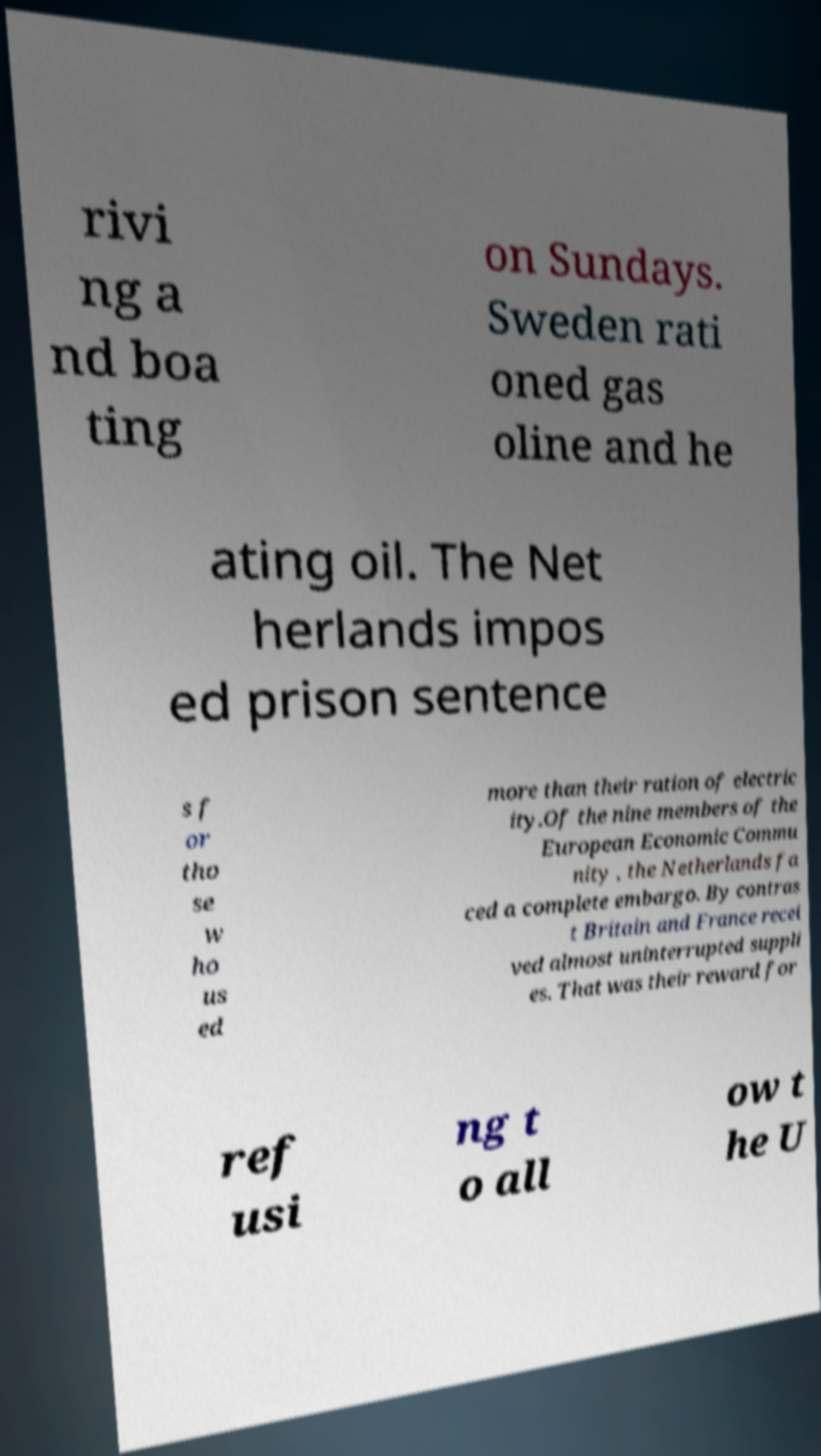What messages or text are displayed in this image? I need them in a readable, typed format. rivi ng a nd boa ting on Sundays. Sweden rati oned gas oline and he ating oil. The Net herlands impos ed prison sentence s f or tho se w ho us ed more than their ration of electric ity.Of the nine members of the European Economic Commu nity , the Netherlands fa ced a complete embargo. By contras t Britain and France recei ved almost uninterrupted suppli es. That was their reward for ref usi ng t o all ow t he U 